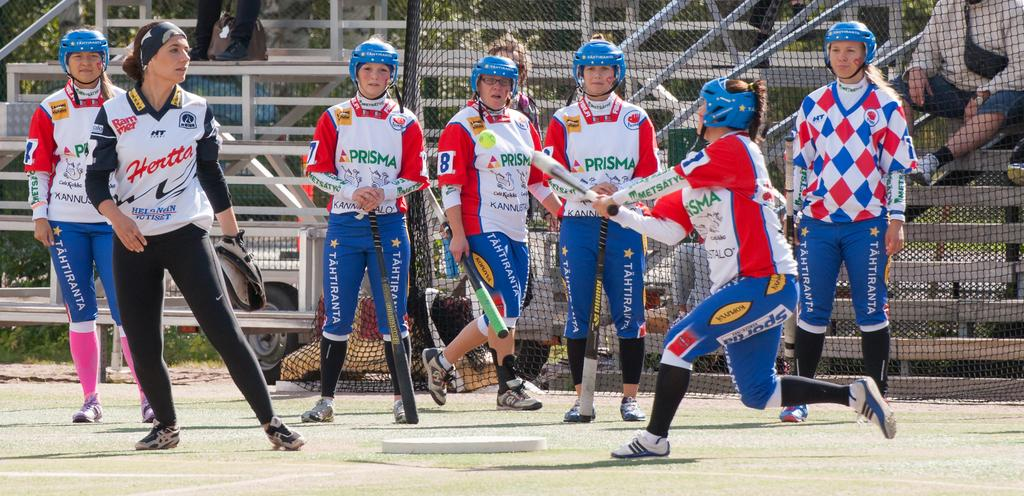What sport are the women playing in the image? The women are playing baseball in the image. What protective gear are the women wearing? The women are wearing blue helmets. What type of surface is visible at the bottom of the image? There is grass at the bottom of the image. What architectural features can be seen in the background of the image? There is fencing and steps in the background of the image. What type of sail can be seen on the women's uniforms in the image? There is no sail present on the women's uniforms in the image; they are wearing blue helmets. What shape is the baseball field in the image? The provided facts do not mention the shape of the baseball field in the image. 